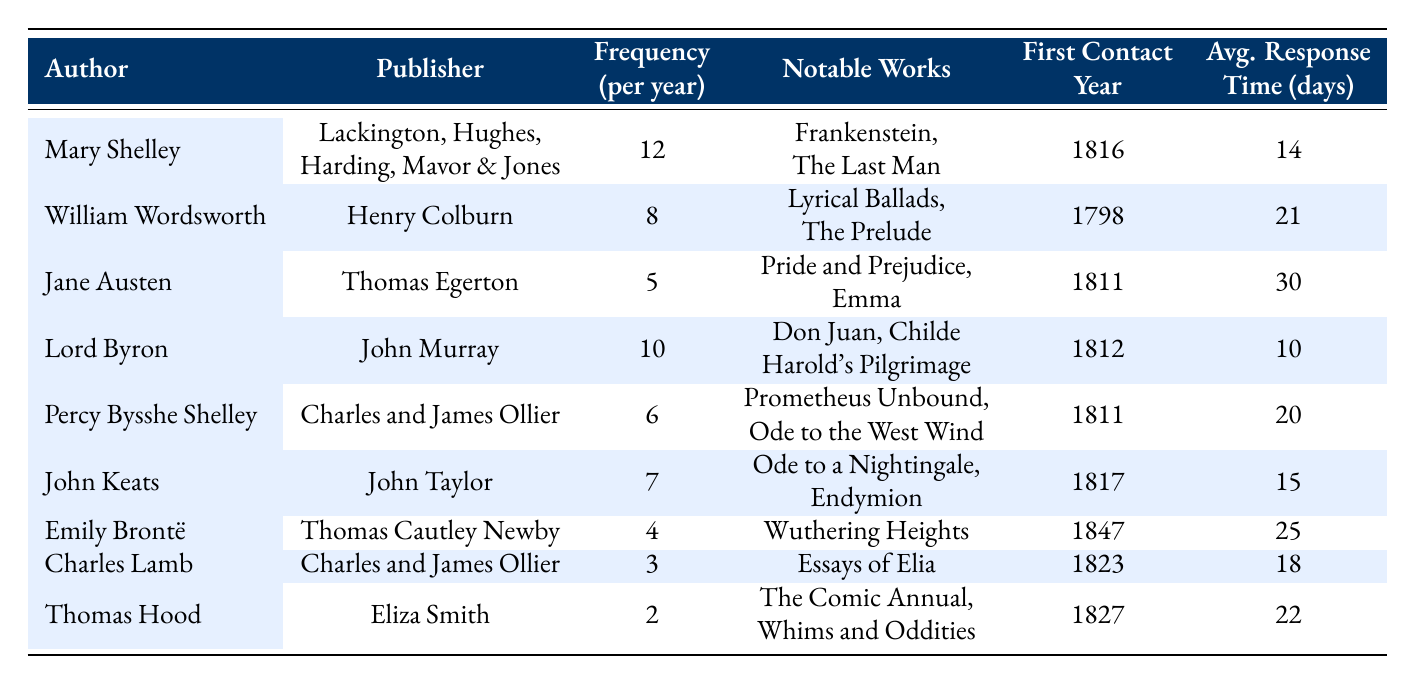What is the frequency per year for Jane Austen? The table shows that Jane Austen has a frequency of 5 per year in correspondence with her publisher, Thomas Egerton.
Answer: 5 Which author had the first contact in the year 1811? Upon reviewing the table, both Percy Bysshe Shelley and Jane Austen first contacted their respective publishers in the year 1811.
Answer: Percy Bysshe Shelley and Jane Austen What is the average response time for correspondence with Mary Shelley? From the table, it is noted that Mary Shelley has an average response time of 14 days for her correspondence with her publisher.
Answer: 14 days Who had the highest frequency of correspondence with their publisher? The data indicates that Mary Shelley has the highest frequency of correspondence at 12 times per year with her publisher, Lackington, Hughes, Harding, Mavor & Jones.
Answer: Mary Shelley Are there any authors who corresponded with their publishers more than seven times a year? By examining the table, it can be seen that Mary Shelley (12 times), Lord Byron (10 times), and William Wordsworth (8 times) all corresponded more than seven times annually with their publishers.
Answer: Yes What is the difference in correspondence frequency between Charles Lamb and John Keats? The table reveals that Charles Lamb corresponds 3 times per year, while John Keats corresponds 7 times per year. The difference is calculated as 7 - 3 = 4.
Answer: 4 Identify the publisher with the longest average response time based on the table. By inspecting the response times listed, it can be determined that Jane Austen has the longest average response time of 30 days with her publisher, Thomas Egerton.
Answer: Thomas Egerton What is the lowest frequency of correspondence observed among the authors listed? The table indicates that Thomas Hood has the lowest frequency of correspondence at 2 times per year with his publisher, Eliza Smith.
Answer: 2 How many notable works did Lord Byron publish? The table records that Lord Byron has two notable works: "Don Juan" and "Childe Harold's Pilgrimage."
Answer: 2 What is the average correspondence frequency for authors who contacted their publishers in the 1810s? The relevant authors, Mary Shelley, Lord Byron, Percy Bysshe Shelley, and John Keats, have frequencies of 12, 10, 6, and 7, respectively. Adding these gives a total of 35, and there are 4 authors, so the average is 35/4 = 8.75.
Answer: 8.75 